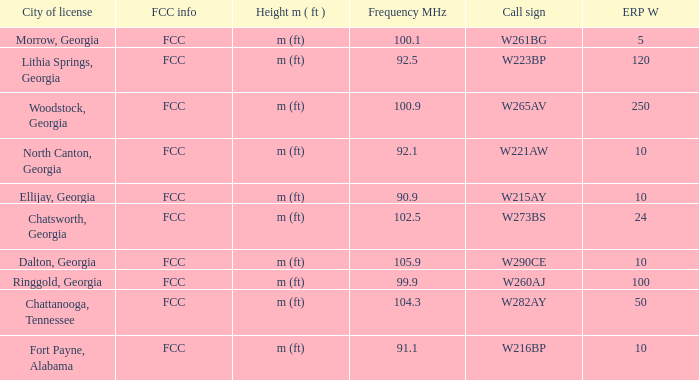How many ERP W is it that has a Call sign of w273bs? 24.0. 